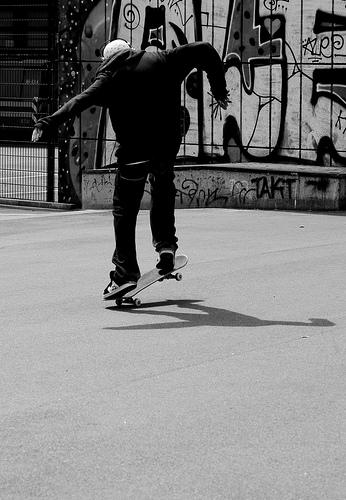Provide a concise description of the background and the main subject's activity. A man skateboards near a graffiti-covered wall and a fence, casting a shadow on the grey ground. Explain the dynamic activity demonstrated by the subject in the given picture. A man skillfully skateboards on a slanted board, with his foot near the wheel, against a backdrop of graffiti and tagging. Mention the main subject's interaction with the skateboard and its elements in the image. The man on the skateboard is balancing expertly with one of his shoes touching a wheel, as the skateboard is tilted. In a few words, describe the primary focus of the image and what the person is doing. A stylish man is expertly riding a tilted skateboard near a graffiti-filled wall. Summarize the main character's outfit in the image. The man is wearing a black sweater, hoodie, dark jeans, tennis shoes, and a hat while riding a skateboard. Convey what the man on the skateboard is wearing in a detailed manner. The skateboarder dons a black sweater, dark jeans, a hoodie, a hat, and tennis shoes as he rides his skateboard. Illustrate the action captured in the image involving the main subject. The man is skillfully riding his skateboard while sporting a fashionable outfit amidst a background of graffiti and tagging. Depict the primary activity happening in the photograph. A boy on a skateboard is performing a trick, with his shadow clearly visible on the grey ground. Recount the main subject's attire and the probable location of this image. The man is wearing a hoodie, jeans, and tennis shoes while skateboarding next to a wall featuring graffiti artwork. Elucidate the environment of the picture and its visual elements. The image features a man skateboarding near a wall with graffiti, a fence, and tagging, as well as his shadow on the ground. 